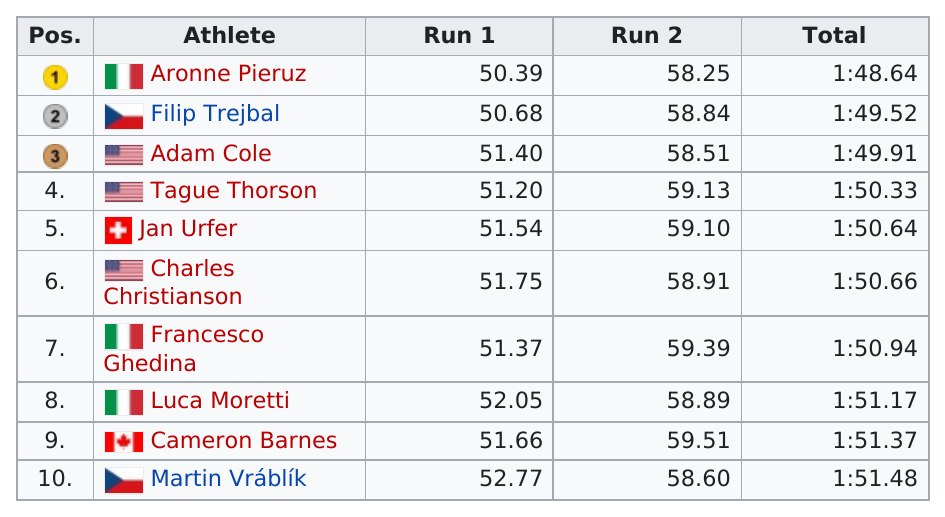Draw attention to some important aspects in this diagram. The person who finished in last place is Martin Vráblík. Luca Moretti's second run occurred at a time of 58.89 seconds. How many athletes' first run was between 51 and 52 seconds? Six athletes had a first run within this range. Aronne Pieruz finished in first place. Aronne Pierre took first place among the athletes. 